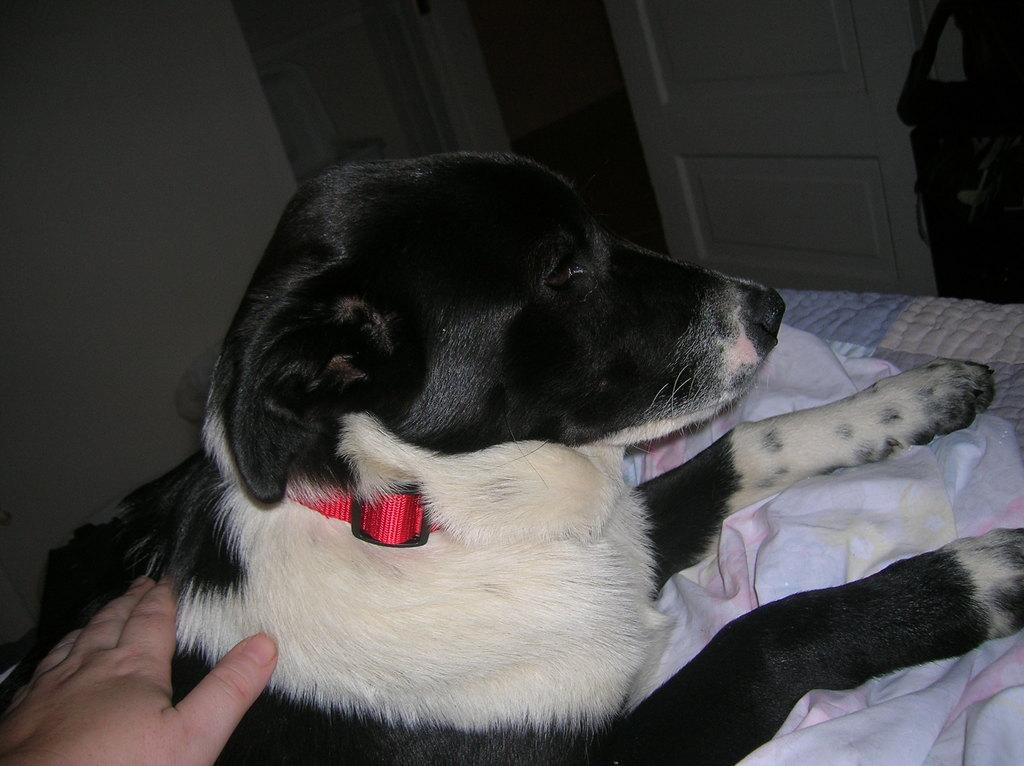What type of animal is in the image? There is a dog in the image. What colors can be seen on the dog? The dog is cream and black in color. What is the interaction between the dog and a human in the image? A human hand is on the dog. What can be seen in the background of the image? There is a wall and a door in the background of the image, along with other objects. How many stitches are visible on the dog's fur in the image? There are no visible stitches on the dog's fur in the image, as it is a real dog and not a stuffed animal or fabric creation. What type of giants can be seen in the image? There are no giants present in the image; it features a dog and a human hand. 